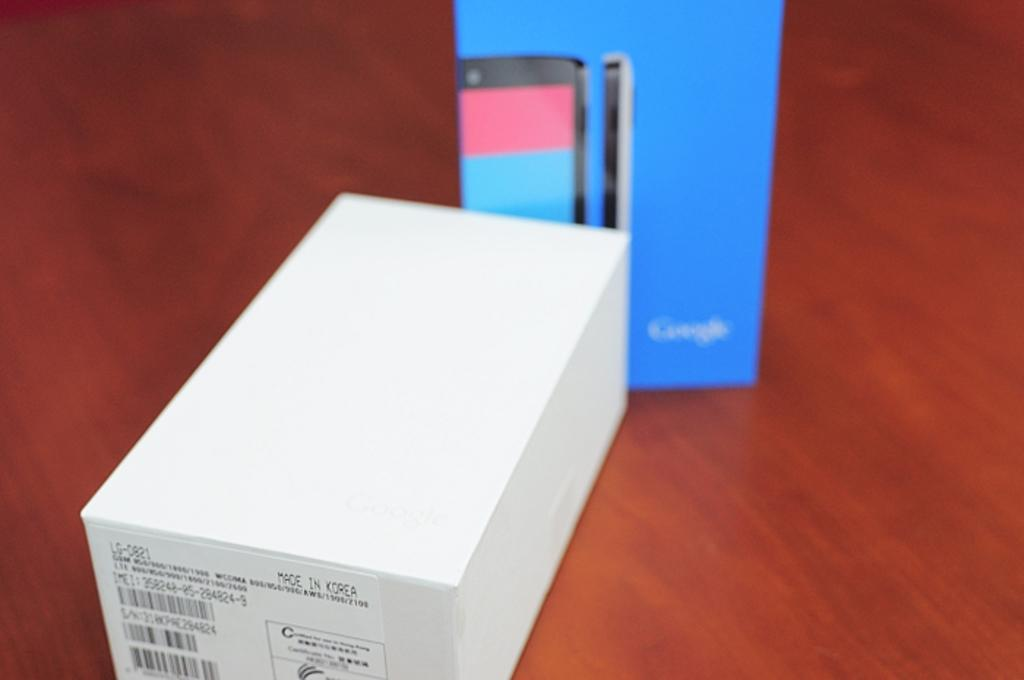Provide a one-sentence caption for the provided image. A box that says made in China is in front of a google box. 